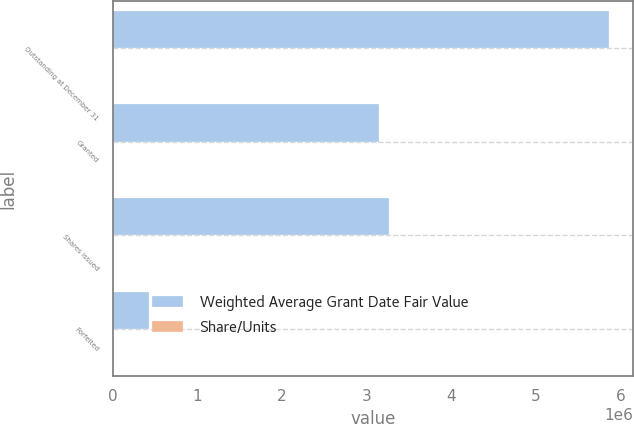Convert chart. <chart><loc_0><loc_0><loc_500><loc_500><stacked_bar_chart><ecel><fcel>Outstanding at December 31<fcel>Granted<fcel>Shares issued<fcel>Forfeited<nl><fcel>Weighted Average Grant Date Fair Value<fcel>5.85773e+06<fcel>3.14844e+06<fcel>3.26276e+06<fcel>429051<nl><fcel>Share/Units<fcel>38.69<fcel>40.76<fcel>32.48<fcel>34.58<nl></chart> 